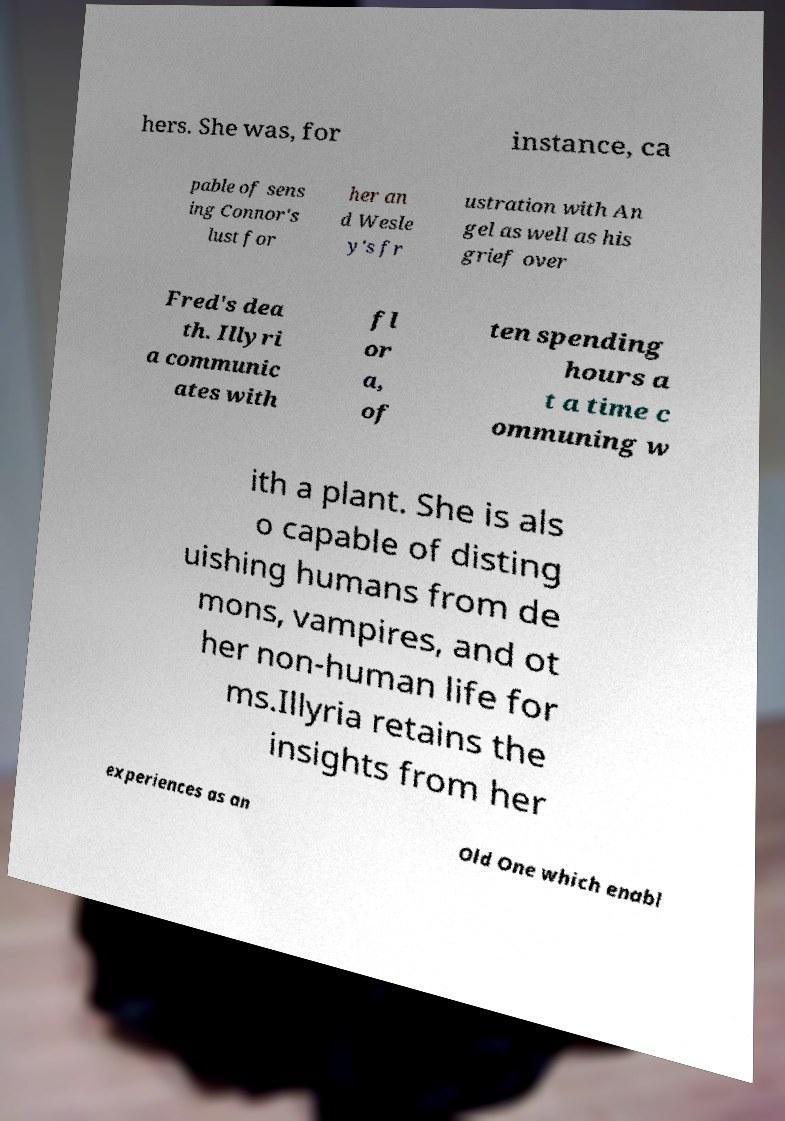Could you extract and type out the text from this image? hers. She was, for instance, ca pable of sens ing Connor's lust for her an d Wesle y's fr ustration with An gel as well as his grief over Fred's dea th. Illyri a communic ates with fl or a, of ten spending hours a t a time c ommuning w ith a plant. She is als o capable of disting uishing humans from de mons, vampires, and ot her non-human life for ms.Illyria retains the insights from her experiences as an Old One which enabl 